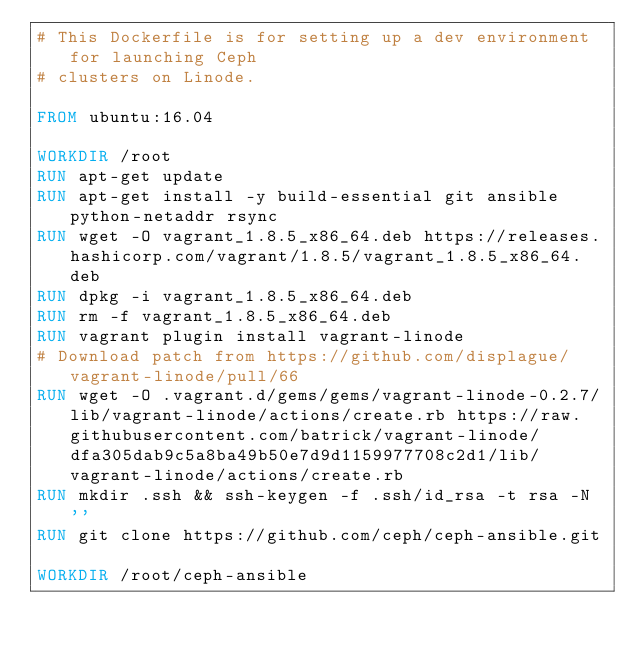Convert code to text. <code><loc_0><loc_0><loc_500><loc_500><_Dockerfile_># This Dockerfile is for setting up a dev environment for launching Ceph
# clusters on Linode.

FROM ubuntu:16.04

WORKDIR /root
RUN apt-get update
RUN apt-get install -y build-essential git ansible python-netaddr rsync
RUN wget -O vagrant_1.8.5_x86_64.deb https://releases.hashicorp.com/vagrant/1.8.5/vagrant_1.8.5_x86_64.deb
RUN dpkg -i vagrant_1.8.5_x86_64.deb
RUN rm -f vagrant_1.8.5_x86_64.deb
RUN vagrant plugin install vagrant-linode
# Download patch from https://github.com/displague/vagrant-linode/pull/66
RUN wget -O .vagrant.d/gems/gems/vagrant-linode-0.2.7/lib/vagrant-linode/actions/create.rb https://raw.githubusercontent.com/batrick/vagrant-linode/dfa305dab9c5a8ba49b50e7d9d1159977708c2d1/lib/vagrant-linode/actions/create.rb
RUN mkdir .ssh && ssh-keygen -f .ssh/id_rsa -t rsa -N ''
RUN git clone https://github.com/ceph/ceph-ansible.git

WORKDIR /root/ceph-ansible
</code> 